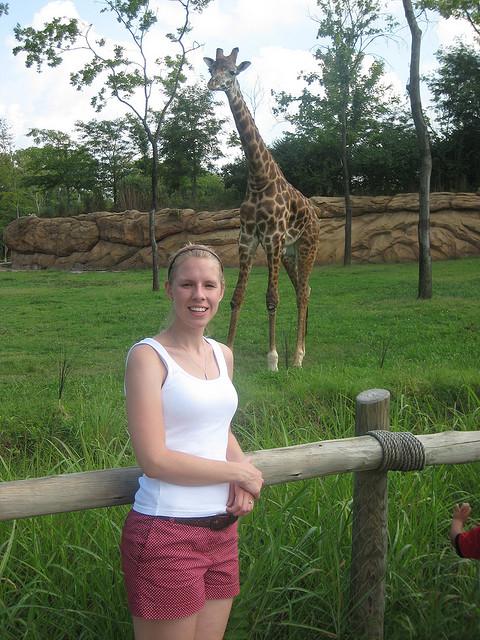Would this fence effective at keeping small animals out?
Answer briefly. No. Is there a rock wall behind the giraffe?
Write a very short answer. Yes. What is the woman doing?
Give a very brief answer. Posing. 